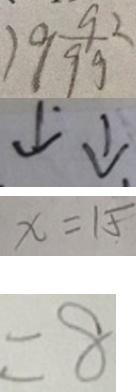<formula> <loc_0><loc_0><loc_500><loc_500>1 9 \frac { 9 2 } { 9 9 } 
 \downarrow ^ { \cdot } \downarrow . 
 x = 1 5 
 = 8</formula> 